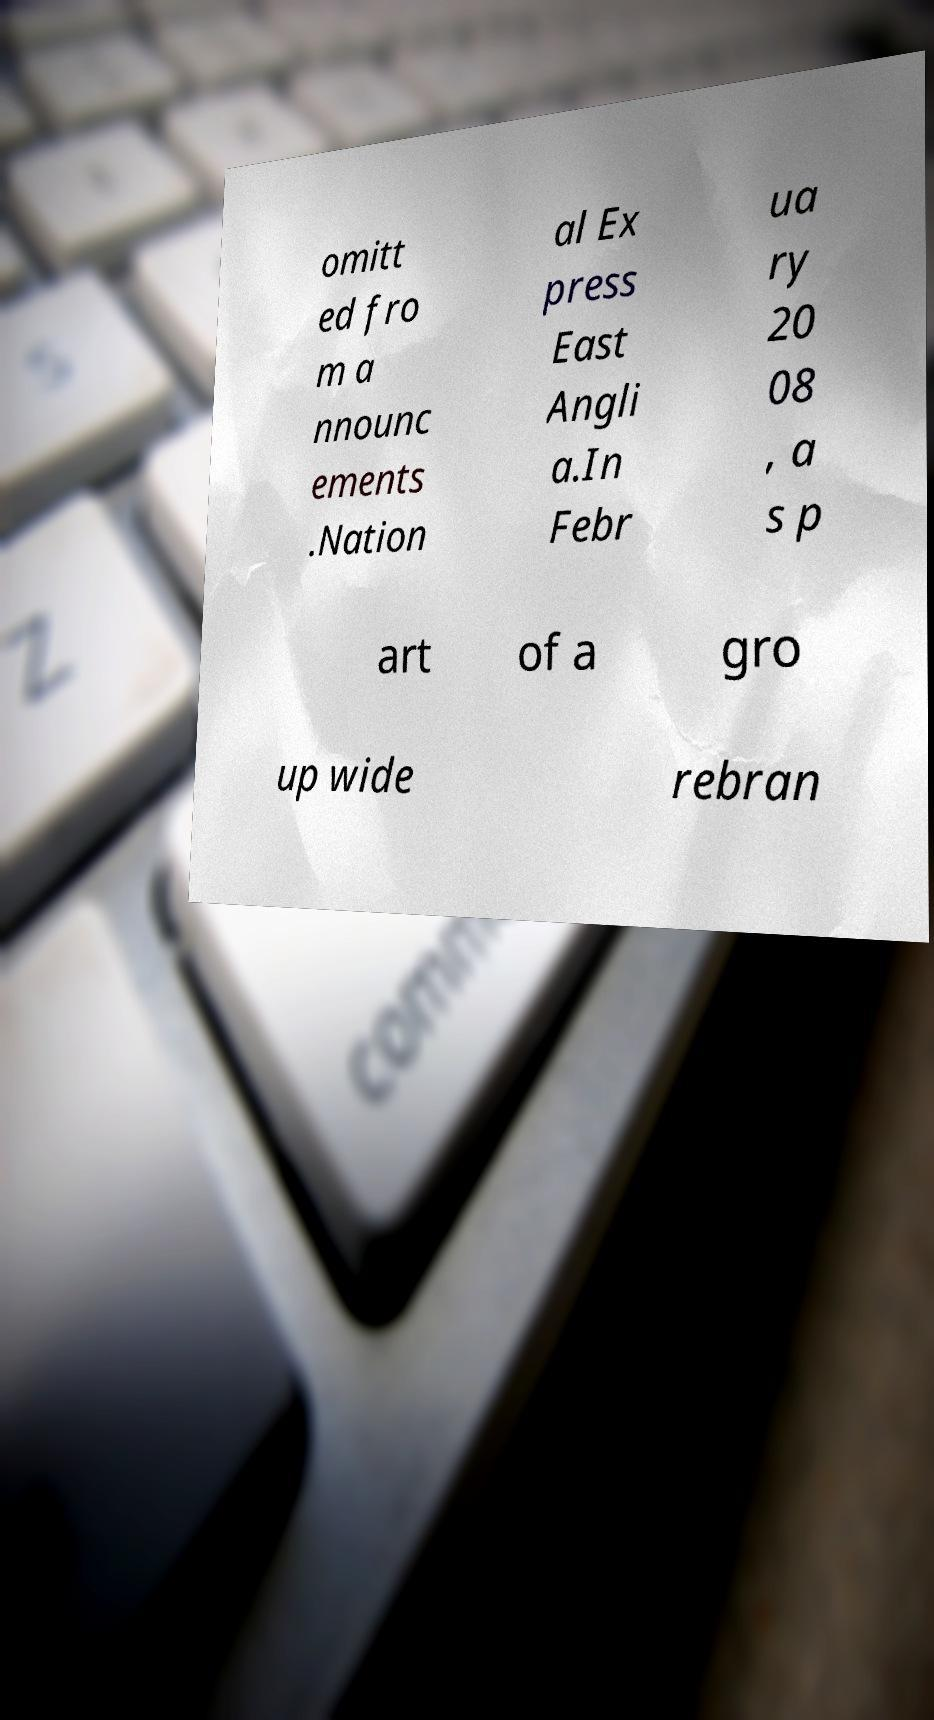Please read and relay the text visible in this image. What does it say? omitt ed fro m a nnounc ements .Nation al Ex press East Angli a.In Febr ua ry 20 08 , a s p art of a gro up wide rebran 